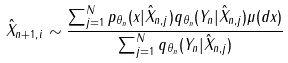<formula> <loc_0><loc_0><loc_500><loc_500>\hat { X } _ { n + 1 , i } \sim \frac { \sum _ { j = 1 } ^ { N } p _ { \theta _ { n } } ( x | \hat { X } _ { n , j } ) q _ { \theta _ { n } } ( Y _ { n } | \hat { X } _ { n , j } ) \mu ( d x ) } { \sum _ { j = 1 } ^ { N } q _ { \theta _ { n } } ( Y _ { n } | \hat { X } _ { n , j } ) }</formula> 